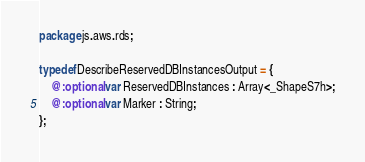Convert code to text. <code><loc_0><loc_0><loc_500><loc_500><_Haxe_>package js.aws.rds;

typedef DescribeReservedDBInstancesOutput = {
    @:optional var ReservedDBInstances : Array<_ShapeS7h>;
    @:optional var Marker : String;
};
</code> 